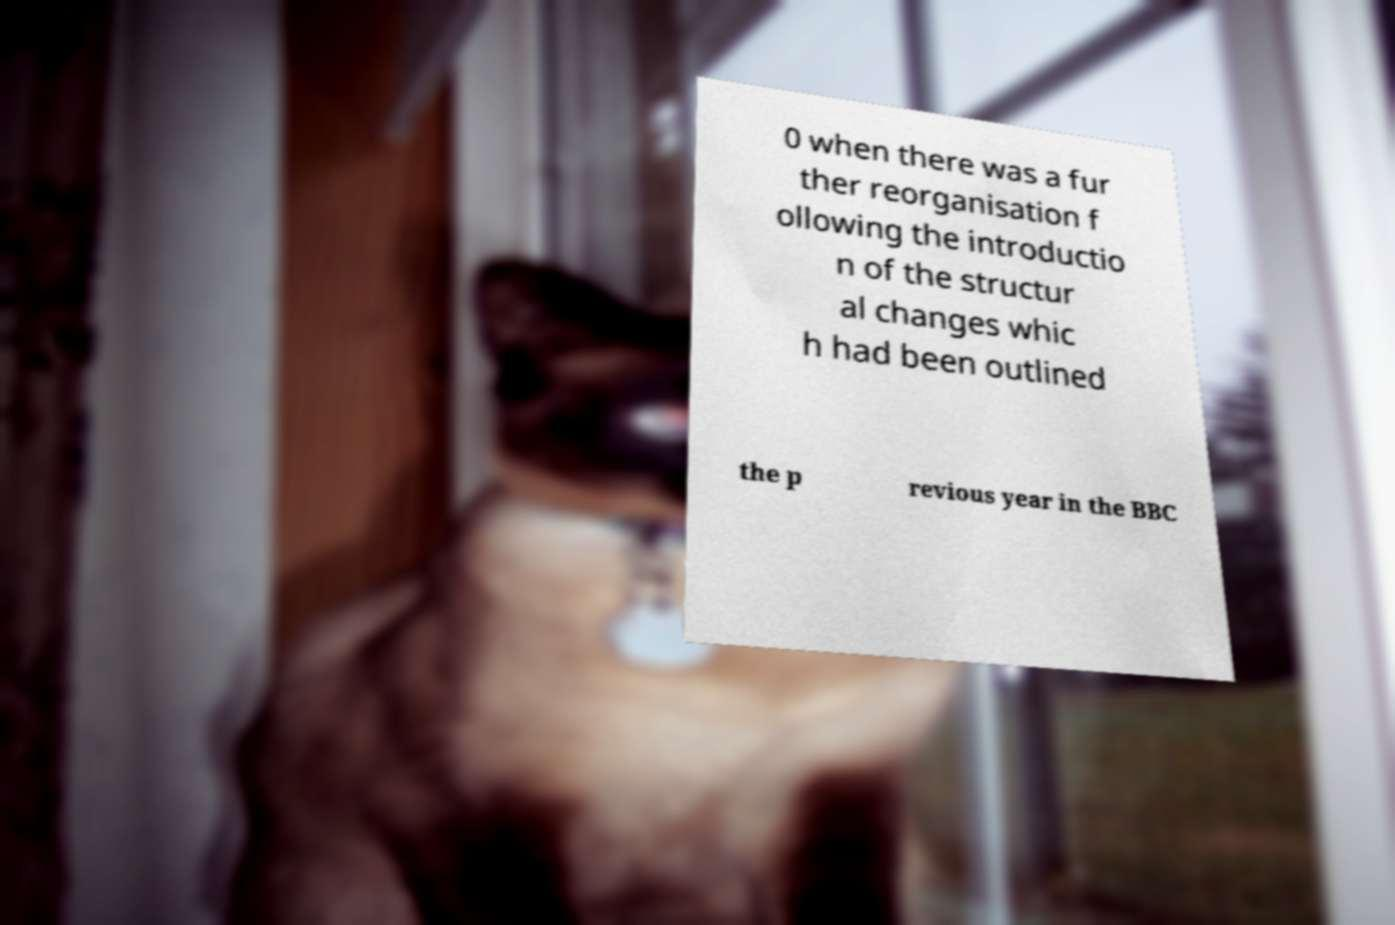Please read and relay the text visible in this image. What does it say? 0 when there was a fur ther reorganisation f ollowing the introductio n of the structur al changes whic h had been outlined the p revious year in the BBC 